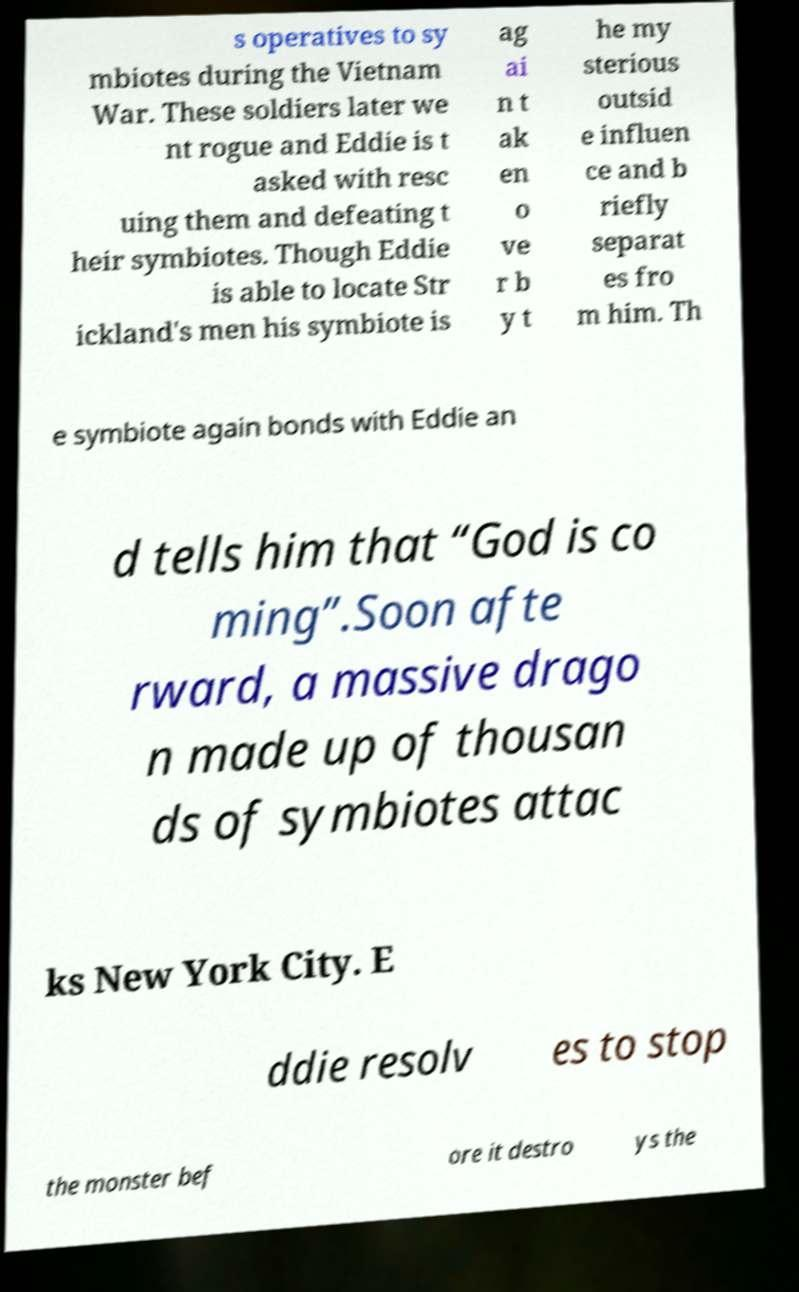What messages or text are displayed in this image? I need them in a readable, typed format. s operatives to sy mbiotes during the Vietnam War. These soldiers later we nt rogue and Eddie is t asked with resc uing them and defeating t heir symbiotes. Though Eddie is able to locate Str ickland's men his symbiote is ag ai n t ak en o ve r b y t he my sterious outsid e influen ce and b riefly separat es fro m him. Th e symbiote again bonds with Eddie an d tells him that “God is co ming”.Soon afte rward, a massive drago n made up of thousan ds of symbiotes attac ks New York City. E ddie resolv es to stop the monster bef ore it destro ys the 